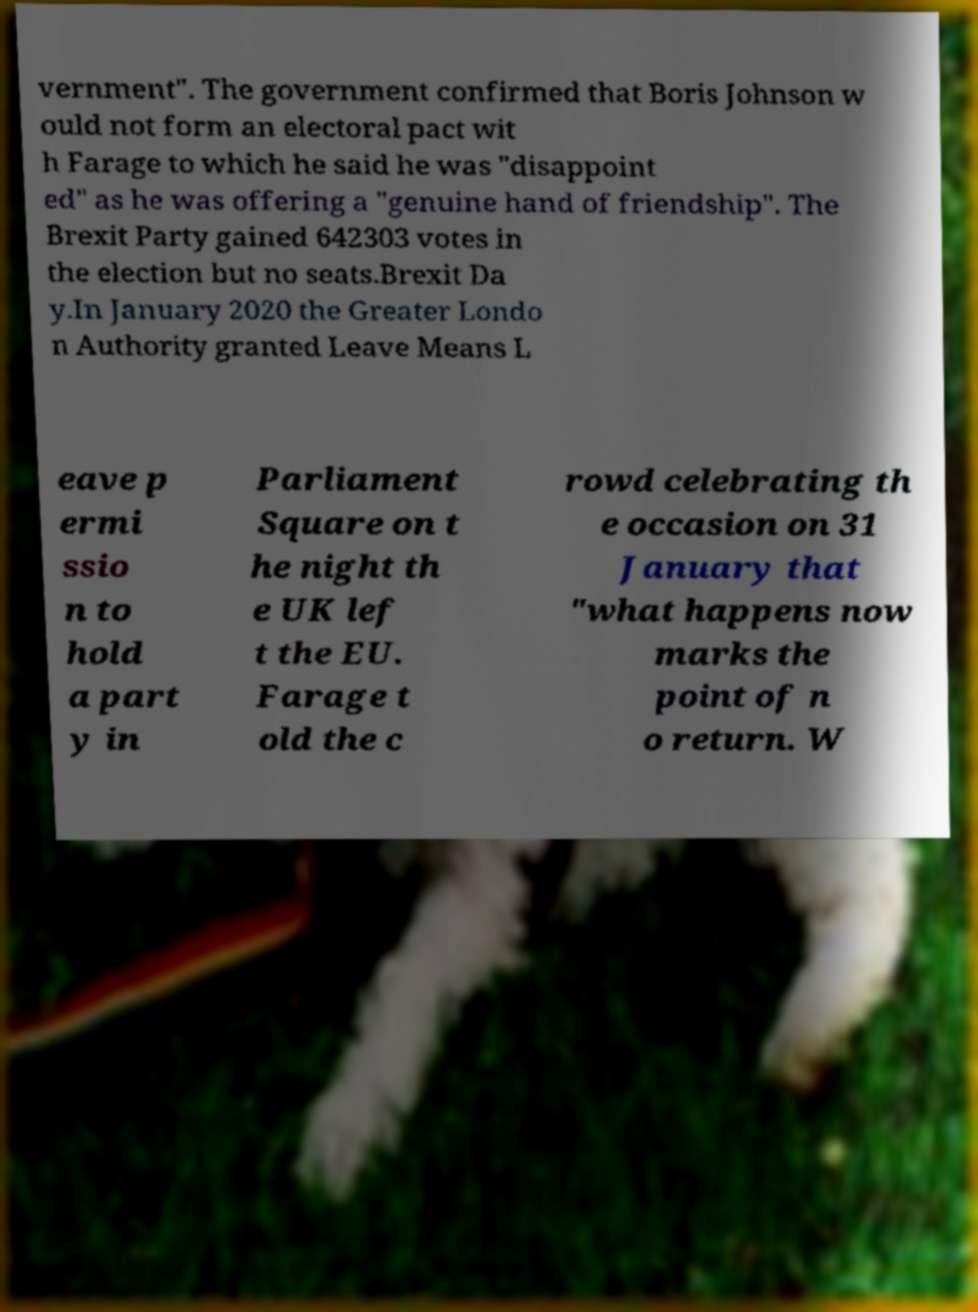Could you extract and type out the text from this image? vernment". The government confirmed that Boris Johnson w ould not form an electoral pact wit h Farage to which he said he was "disappoint ed" as he was offering a "genuine hand of friendship". The Brexit Party gained 642303 votes in the election but no seats.Brexit Da y.In January 2020 the Greater Londo n Authority granted Leave Means L eave p ermi ssio n to hold a part y in Parliament Square on t he night th e UK lef t the EU. Farage t old the c rowd celebrating th e occasion on 31 January that "what happens now marks the point of n o return. W 